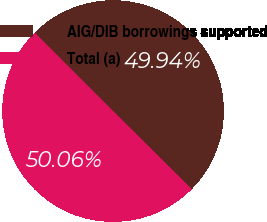Convert chart. <chart><loc_0><loc_0><loc_500><loc_500><pie_chart><fcel>AIG/DIB borrowings supported<fcel>Total (a)<nl><fcel>49.94%<fcel>50.06%<nl></chart> 